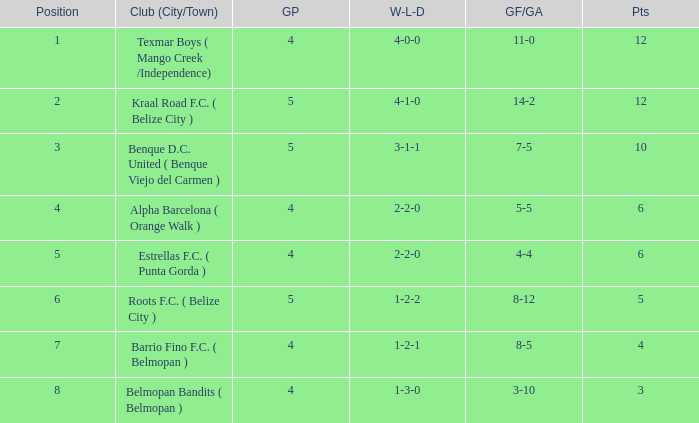Who is the the club (city/town) with goals for/against being 14-2 Kraal Road F.C. ( Belize City ). Parse the table in full. {'header': ['Position', 'Club (City/Town)', 'GP', 'W-L-D', 'GF/GA', 'Pts'], 'rows': [['1', 'Texmar Boys ( Mango Creek /Independence)', '4', '4-0-0', '11-0', '12'], ['2', 'Kraal Road F.C. ( Belize City )', '5', '4-1-0', '14-2', '12'], ['3', 'Benque D.C. United ( Benque Viejo del Carmen )', '5', '3-1-1', '7-5', '10'], ['4', 'Alpha Barcelona ( Orange Walk )', '4', '2-2-0', '5-5', '6'], ['5', 'Estrellas F.C. ( Punta Gorda )', '4', '2-2-0', '4-4', '6'], ['6', 'Roots F.C. ( Belize City )', '5', '1-2-2', '8-12', '5'], ['7', 'Barrio Fino F.C. ( Belmopan )', '4', '1-2-1', '8-5', '4'], ['8', 'Belmopan Bandits ( Belmopan )', '4', '1-3-0', '3-10', '3']]} 